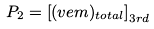Convert formula to latex. <formula><loc_0><loc_0><loc_500><loc_500>P _ { 2 } = \left [ ( v e m ) _ { t o t a l } \right ] _ { 3 r d }</formula> 